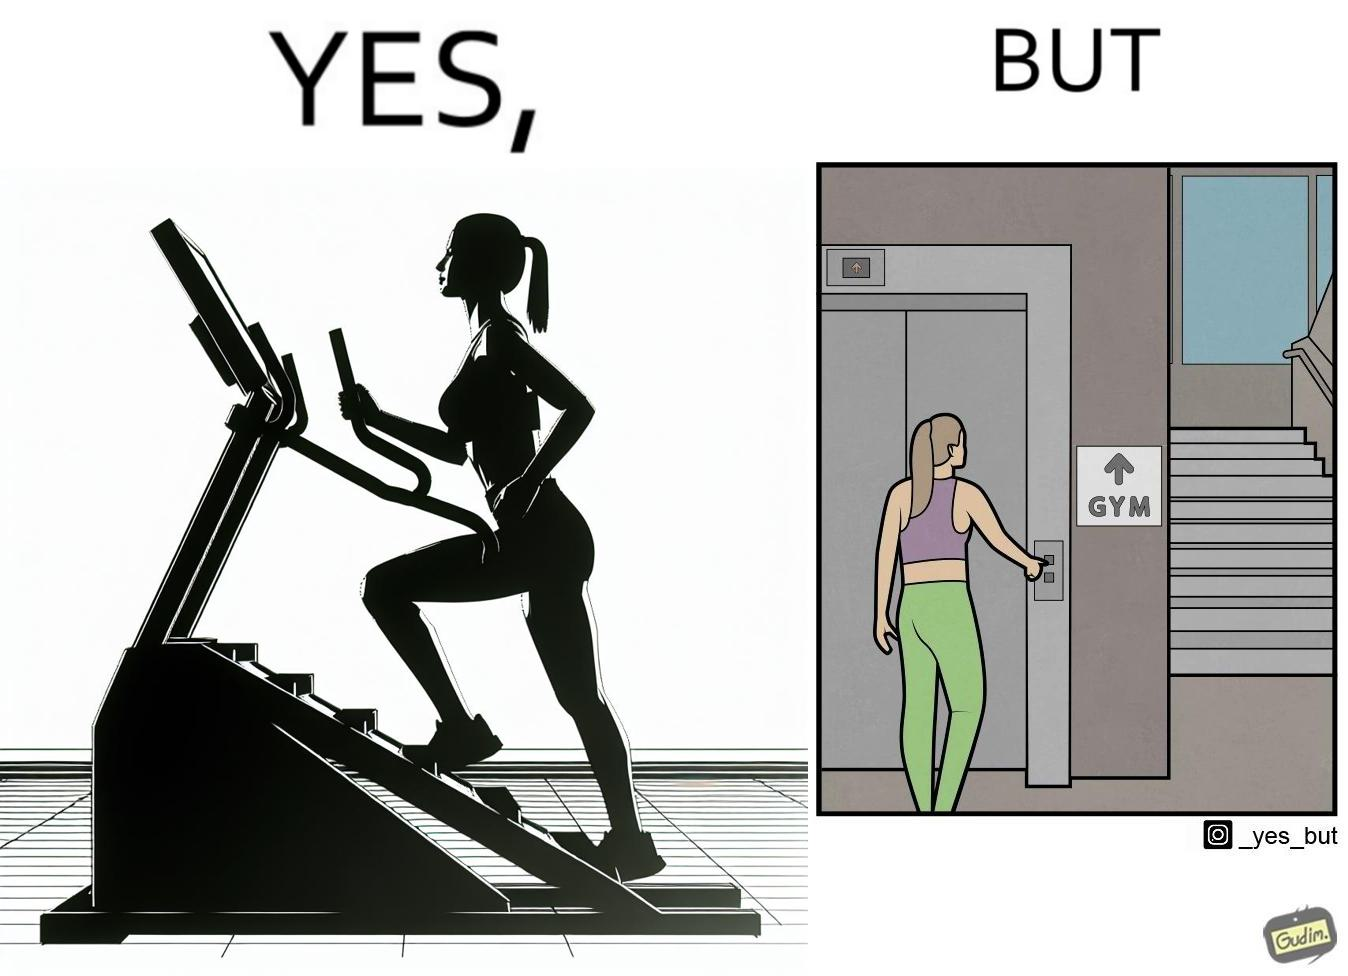Describe what you see in this image. The image is ironic, because in the left image a woman is seen using the stair climber machine at the gym but the same woman is not ready to climb up some stairs for going to the gym and is calling for the lift 